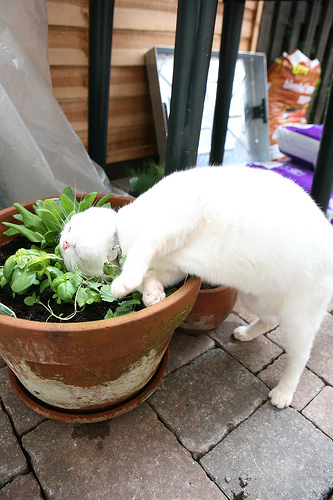What animal is on the sidewalk? The animal on the sidewalk is a cat. 